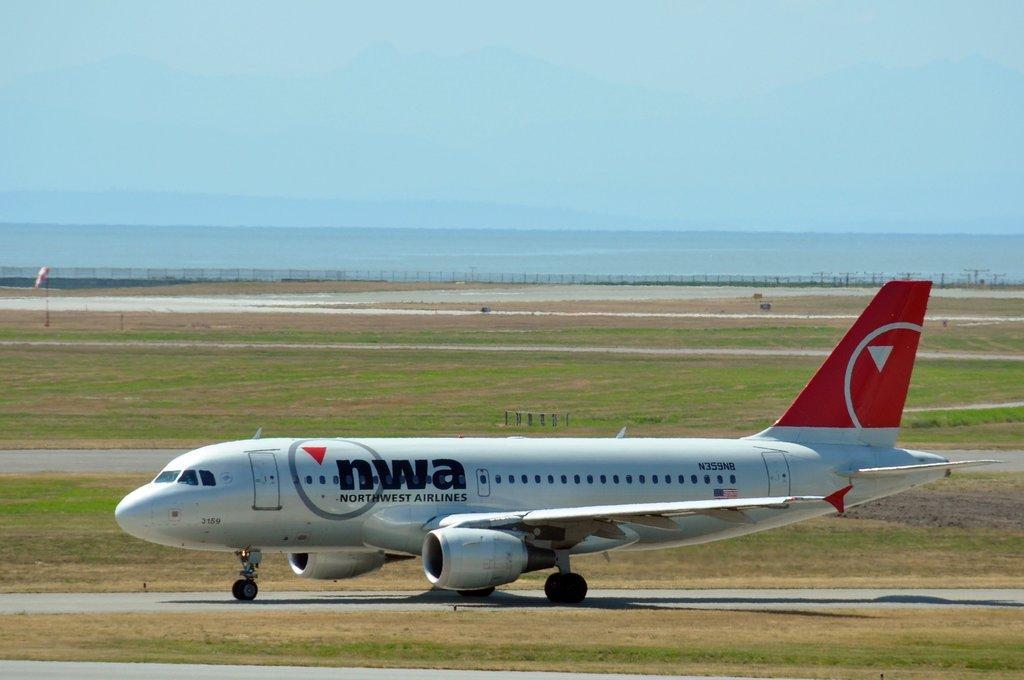In one or two sentences, can you explain what this image depicts? As we can see in the image there is grass, plane and in the background there is fence. On the top there is sky. 